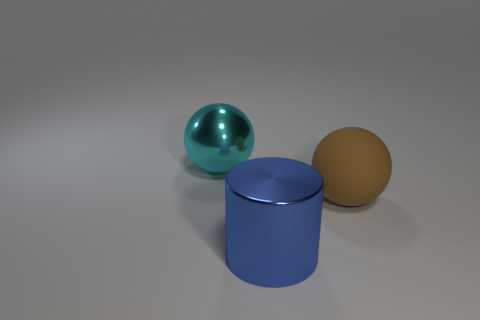What might be the purpose of these objects if they were real? If these objects were real, the large sphere could serve a decorative purpose due to its reflective surface, perhaps as an ornamental piece. The cylinder might function as a container, storage, or even as a simple structural element. The sphere on the right, with its matte finish, could be a lightweight ball used for recreational activities. 